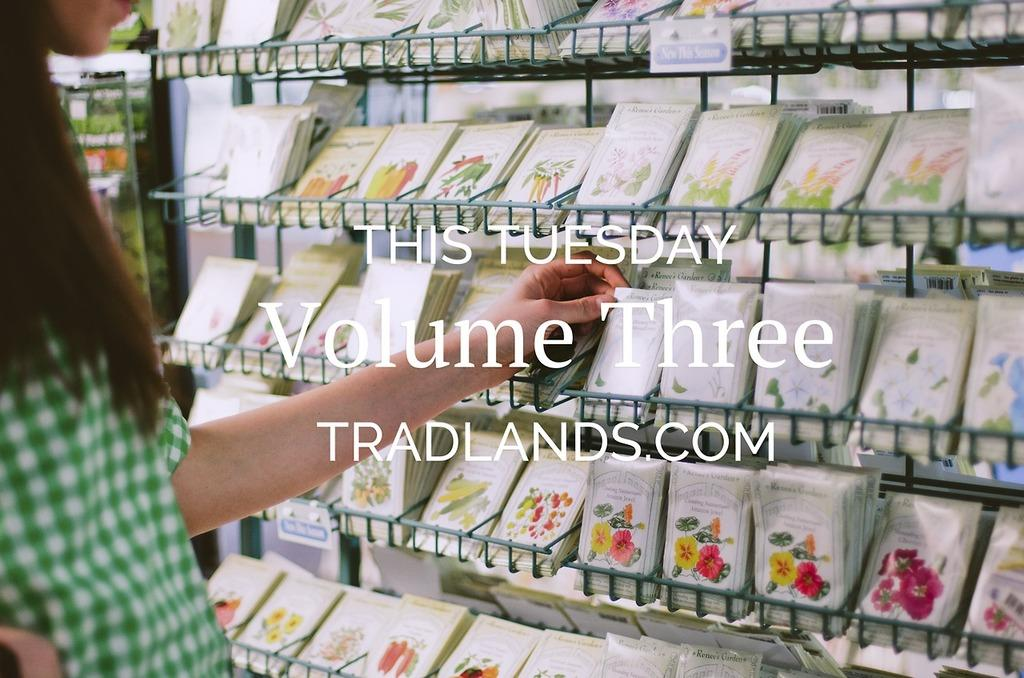<image>
Describe the image concisely. Ad showing a woman shopping for something and the words "This Tuesday" in white. 